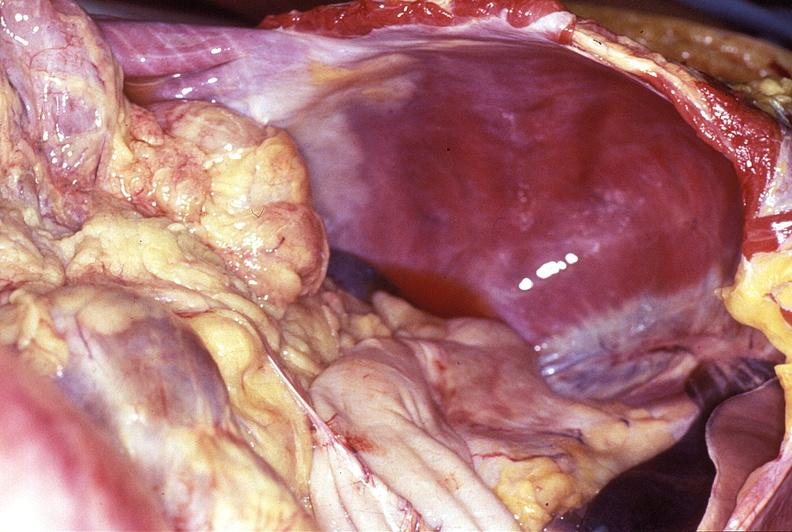s gastrointestinal present?
Answer the question using a single word or phrase. Yes 